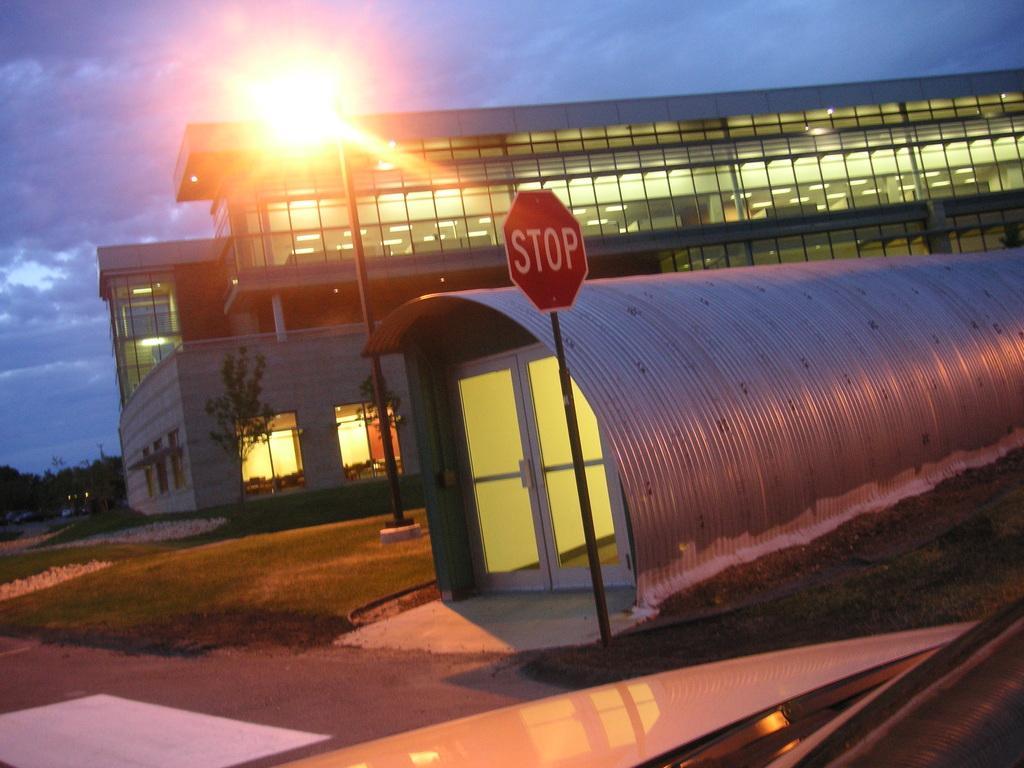<image>
Relay a brief, clear account of the picture shown. A stop sign outside of a quarter quonset hut. 